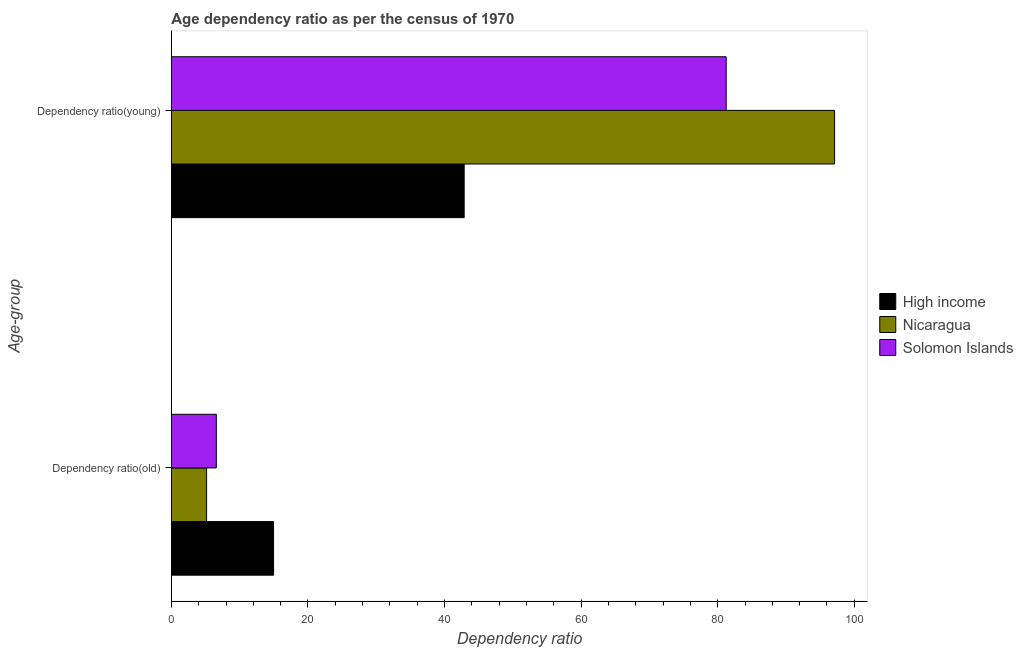Are the number of bars per tick equal to the number of legend labels?
Provide a short and direct response. Yes. Are the number of bars on each tick of the Y-axis equal?
Your response must be concise. Yes. How many bars are there on the 1st tick from the bottom?
Provide a succinct answer. 3. What is the label of the 2nd group of bars from the top?
Your answer should be compact. Dependency ratio(old). What is the age dependency ratio(old) in High income?
Provide a succinct answer. 14.97. Across all countries, what is the maximum age dependency ratio(old)?
Give a very brief answer. 14.97. Across all countries, what is the minimum age dependency ratio(young)?
Provide a short and direct response. 42.87. In which country was the age dependency ratio(old) maximum?
Your answer should be very brief. High income. What is the total age dependency ratio(old) in the graph?
Provide a succinct answer. 26.7. What is the difference between the age dependency ratio(old) in Solomon Islands and that in Nicaragua?
Your answer should be very brief. 1.43. What is the difference between the age dependency ratio(old) in Nicaragua and the age dependency ratio(young) in Solomon Islands?
Your answer should be very brief. -76.08. What is the average age dependency ratio(old) per country?
Ensure brevity in your answer.  8.9. What is the difference between the age dependency ratio(young) and age dependency ratio(old) in Solomon Islands?
Provide a succinct answer. 74.66. In how many countries, is the age dependency ratio(old) greater than 4 ?
Make the answer very short. 3. What is the ratio of the age dependency ratio(old) in Nicaragua to that in High income?
Give a very brief answer. 0.34. Is the age dependency ratio(young) in High income less than that in Solomon Islands?
Offer a terse response. Yes. In how many countries, is the age dependency ratio(old) greater than the average age dependency ratio(old) taken over all countries?
Give a very brief answer. 1. What does the 3rd bar from the top in Dependency ratio(old) represents?
Your response must be concise. High income. What does the 3rd bar from the bottom in Dependency ratio(young) represents?
Provide a succinct answer. Solomon Islands. Are all the bars in the graph horizontal?
Provide a short and direct response. Yes. Does the graph contain any zero values?
Offer a very short reply. No. Where does the legend appear in the graph?
Make the answer very short. Center right. How many legend labels are there?
Offer a very short reply. 3. How are the legend labels stacked?
Ensure brevity in your answer.  Vertical. What is the title of the graph?
Give a very brief answer. Age dependency ratio as per the census of 1970. Does "South Sudan" appear as one of the legend labels in the graph?
Your response must be concise. No. What is the label or title of the X-axis?
Your answer should be very brief. Dependency ratio. What is the label or title of the Y-axis?
Provide a succinct answer. Age-group. What is the Dependency ratio of High income in Dependency ratio(old)?
Your response must be concise. 14.97. What is the Dependency ratio in Nicaragua in Dependency ratio(old)?
Keep it short and to the point. 5.16. What is the Dependency ratio of Solomon Islands in Dependency ratio(old)?
Your answer should be compact. 6.58. What is the Dependency ratio of High income in Dependency ratio(young)?
Offer a terse response. 42.87. What is the Dependency ratio of Nicaragua in Dependency ratio(young)?
Your answer should be compact. 97.11. What is the Dependency ratio of Solomon Islands in Dependency ratio(young)?
Offer a terse response. 81.24. Across all Age-group, what is the maximum Dependency ratio of High income?
Your answer should be compact. 42.87. Across all Age-group, what is the maximum Dependency ratio of Nicaragua?
Make the answer very short. 97.11. Across all Age-group, what is the maximum Dependency ratio of Solomon Islands?
Your answer should be very brief. 81.24. Across all Age-group, what is the minimum Dependency ratio of High income?
Ensure brevity in your answer.  14.97. Across all Age-group, what is the minimum Dependency ratio in Nicaragua?
Ensure brevity in your answer.  5.16. Across all Age-group, what is the minimum Dependency ratio of Solomon Islands?
Make the answer very short. 6.58. What is the total Dependency ratio of High income in the graph?
Provide a succinct answer. 57.84. What is the total Dependency ratio of Nicaragua in the graph?
Provide a short and direct response. 102.27. What is the total Dependency ratio of Solomon Islands in the graph?
Your answer should be very brief. 87.82. What is the difference between the Dependency ratio in High income in Dependency ratio(old) and that in Dependency ratio(young)?
Give a very brief answer. -27.91. What is the difference between the Dependency ratio of Nicaragua in Dependency ratio(old) and that in Dependency ratio(young)?
Offer a terse response. -91.96. What is the difference between the Dependency ratio of Solomon Islands in Dependency ratio(old) and that in Dependency ratio(young)?
Your answer should be very brief. -74.66. What is the difference between the Dependency ratio in High income in Dependency ratio(old) and the Dependency ratio in Nicaragua in Dependency ratio(young)?
Offer a very short reply. -82.15. What is the difference between the Dependency ratio in High income in Dependency ratio(old) and the Dependency ratio in Solomon Islands in Dependency ratio(young)?
Offer a terse response. -66.27. What is the difference between the Dependency ratio of Nicaragua in Dependency ratio(old) and the Dependency ratio of Solomon Islands in Dependency ratio(young)?
Your answer should be compact. -76.08. What is the average Dependency ratio in High income per Age-group?
Your response must be concise. 28.92. What is the average Dependency ratio in Nicaragua per Age-group?
Provide a succinct answer. 51.13. What is the average Dependency ratio of Solomon Islands per Age-group?
Your answer should be compact. 43.91. What is the difference between the Dependency ratio of High income and Dependency ratio of Nicaragua in Dependency ratio(old)?
Your answer should be very brief. 9.81. What is the difference between the Dependency ratio in High income and Dependency ratio in Solomon Islands in Dependency ratio(old)?
Provide a short and direct response. 8.38. What is the difference between the Dependency ratio in Nicaragua and Dependency ratio in Solomon Islands in Dependency ratio(old)?
Your answer should be very brief. -1.43. What is the difference between the Dependency ratio of High income and Dependency ratio of Nicaragua in Dependency ratio(young)?
Offer a very short reply. -54.24. What is the difference between the Dependency ratio in High income and Dependency ratio in Solomon Islands in Dependency ratio(young)?
Ensure brevity in your answer.  -38.36. What is the difference between the Dependency ratio of Nicaragua and Dependency ratio of Solomon Islands in Dependency ratio(young)?
Keep it short and to the point. 15.88. What is the ratio of the Dependency ratio in High income in Dependency ratio(old) to that in Dependency ratio(young)?
Make the answer very short. 0.35. What is the ratio of the Dependency ratio in Nicaragua in Dependency ratio(old) to that in Dependency ratio(young)?
Give a very brief answer. 0.05. What is the ratio of the Dependency ratio of Solomon Islands in Dependency ratio(old) to that in Dependency ratio(young)?
Your response must be concise. 0.08. What is the difference between the highest and the second highest Dependency ratio in High income?
Provide a succinct answer. 27.91. What is the difference between the highest and the second highest Dependency ratio of Nicaragua?
Give a very brief answer. 91.96. What is the difference between the highest and the second highest Dependency ratio in Solomon Islands?
Ensure brevity in your answer.  74.66. What is the difference between the highest and the lowest Dependency ratio in High income?
Your answer should be very brief. 27.91. What is the difference between the highest and the lowest Dependency ratio of Nicaragua?
Provide a short and direct response. 91.96. What is the difference between the highest and the lowest Dependency ratio in Solomon Islands?
Provide a succinct answer. 74.66. 